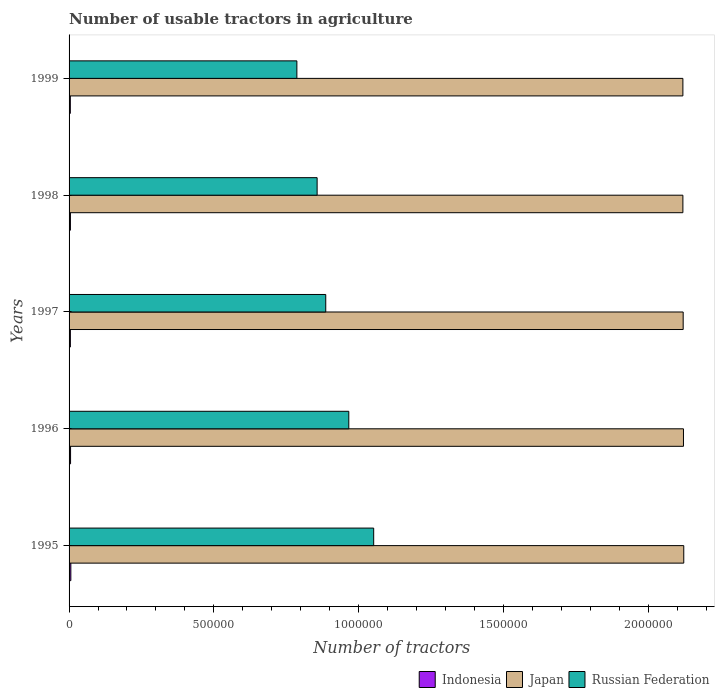Are the number of bars per tick equal to the number of legend labels?
Offer a very short reply. Yes. What is the number of usable tractors in agriculture in Indonesia in 1995?
Make the answer very short. 6124. Across all years, what is the maximum number of usable tractors in agriculture in Russian Federation?
Your response must be concise. 1.05e+06. Across all years, what is the minimum number of usable tractors in agriculture in Indonesia?
Ensure brevity in your answer.  4335. In which year was the number of usable tractors in agriculture in Russian Federation maximum?
Offer a terse response. 1995. What is the total number of usable tractors in agriculture in Japan in the graph?
Your answer should be very brief. 1.06e+07. What is the difference between the number of usable tractors in agriculture in Russian Federation in 1995 and that in 1996?
Ensure brevity in your answer.  8.60e+04. What is the difference between the number of usable tractors in agriculture in Russian Federation in 1997 and the number of usable tractors in agriculture in Indonesia in 1998?
Offer a very short reply. 8.82e+05. What is the average number of usable tractors in agriculture in Indonesia per year?
Provide a short and direct response. 4947.4. In the year 1998, what is the difference between the number of usable tractors in agriculture in Japan and number of usable tractors in agriculture in Russian Federation?
Your answer should be compact. 1.26e+06. What is the ratio of the number of usable tractors in agriculture in Indonesia in 1997 to that in 1999?
Give a very brief answer. 1.03. What is the difference between the highest and the second highest number of usable tractors in agriculture in Indonesia?
Give a very brief answer. 985. What is the difference between the highest and the lowest number of usable tractors in agriculture in Indonesia?
Offer a very short reply. 1789. What does the 1st bar from the top in 1999 represents?
Offer a very short reply. Russian Federation. What does the 3rd bar from the bottom in 1999 represents?
Your answer should be compact. Russian Federation. How many bars are there?
Make the answer very short. 15. How many years are there in the graph?
Offer a very short reply. 5. What is the difference between two consecutive major ticks on the X-axis?
Provide a short and direct response. 5.00e+05. Does the graph contain any zero values?
Your answer should be very brief. No. How many legend labels are there?
Your answer should be compact. 3. What is the title of the graph?
Your response must be concise. Number of usable tractors in agriculture. What is the label or title of the X-axis?
Provide a short and direct response. Number of tractors. What is the label or title of the Y-axis?
Offer a very short reply. Years. What is the Number of tractors of Indonesia in 1995?
Provide a succinct answer. 6124. What is the Number of tractors in Japan in 1995?
Provide a short and direct response. 2.12e+06. What is the Number of tractors of Russian Federation in 1995?
Provide a short and direct response. 1.05e+06. What is the Number of tractors of Indonesia in 1996?
Keep it short and to the point. 5139. What is the Number of tractors of Japan in 1996?
Your answer should be very brief. 2.12e+06. What is the Number of tractors in Russian Federation in 1996?
Make the answer very short. 9.66e+05. What is the Number of tractors of Indonesia in 1997?
Provide a short and direct response. 4483. What is the Number of tractors in Japan in 1997?
Give a very brief answer. 2.12e+06. What is the Number of tractors of Russian Federation in 1997?
Your answer should be very brief. 8.86e+05. What is the Number of tractors in Indonesia in 1998?
Ensure brevity in your answer.  4656. What is the Number of tractors in Japan in 1998?
Provide a succinct answer. 2.12e+06. What is the Number of tractors of Russian Federation in 1998?
Offer a terse response. 8.57e+05. What is the Number of tractors of Indonesia in 1999?
Provide a short and direct response. 4335. What is the Number of tractors in Japan in 1999?
Offer a terse response. 2.12e+06. What is the Number of tractors in Russian Federation in 1999?
Offer a terse response. 7.87e+05. Across all years, what is the maximum Number of tractors in Indonesia?
Keep it short and to the point. 6124. Across all years, what is the maximum Number of tractors in Japan?
Your answer should be compact. 2.12e+06. Across all years, what is the maximum Number of tractors of Russian Federation?
Offer a terse response. 1.05e+06. Across all years, what is the minimum Number of tractors of Indonesia?
Your answer should be compact. 4335. Across all years, what is the minimum Number of tractors of Japan?
Provide a succinct answer. 2.12e+06. Across all years, what is the minimum Number of tractors in Russian Federation?
Provide a succinct answer. 7.87e+05. What is the total Number of tractors of Indonesia in the graph?
Give a very brief answer. 2.47e+04. What is the total Number of tractors in Japan in the graph?
Your response must be concise. 1.06e+07. What is the total Number of tractors in Russian Federation in the graph?
Your response must be concise. 4.55e+06. What is the difference between the Number of tractors of Indonesia in 1995 and that in 1996?
Offer a terse response. 985. What is the difference between the Number of tractors in Japan in 1995 and that in 1996?
Offer a very short reply. 1000. What is the difference between the Number of tractors in Russian Federation in 1995 and that in 1996?
Your answer should be very brief. 8.60e+04. What is the difference between the Number of tractors of Indonesia in 1995 and that in 1997?
Offer a terse response. 1641. What is the difference between the Number of tractors in Russian Federation in 1995 and that in 1997?
Your answer should be compact. 1.66e+05. What is the difference between the Number of tractors in Indonesia in 1995 and that in 1998?
Keep it short and to the point. 1468. What is the difference between the Number of tractors of Japan in 1995 and that in 1998?
Ensure brevity in your answer.  3000. What is the difference between the Number of tractors of Russian Federation in 1995 and that in 1998?
Provide a short and direct response. 1.95e+05. What is the difference between the Number of tractors of Indonesia in 1995 and that in 1999?
Your answer should be very brief. 1789. What is the difference between the Number of tractors in Japan in 1995 and that in 1999?
Ensure brevity in your answer.  3000. What is the difference between the Number of tractors of Russian Federation in 1995 and that in 1999?
Provide a short and direct response. 2.65e+05. What is the difference between the Number of tractors of Indonesia in 1996 and that in 1997?
Give a very brief answer. 656. What is the difference between the Number of tractors in Russian Federation in 1996 and that in 1997?
Keep it short and to the point. 7.96e+04. What is the difference between the Number of tractors in Indonesia in 1996 and that in 1998?
Your response must be concise. 483. What is the difference between the Number of tractors of Japan in 1996 and that in 1998?
Offer a terse response. 2000. What is the difference between the Number of tractors in Russian Federation in 1996 and that in 1998?
Offer a terse response. 1.09e+05. What is the difference between the Number of tractors in Indonesia in 1996 and that in 1999?
Keep it short and to the point. 804. What is the difference between the Number of tractors of Japan in 1996 and that in 1999?
Provide a succinct answer. 2000. What is the difference between the Number of tractors of Russian Federation in 1996 and that in 1999?
Keep it short and to the point. 1.79e+05. What is the difference between the Number of tractors of Indonesia in 1997 and that in 1998?
Provide a succinct answer. -173. What is the difference between the Number of tractors of Japan in 1997 and that in 1998?
Offer a very short reply. 1000. What is the difference between the Number of tractors of Russian Federation in 1997 and that in 1998?
Your answer should be compact. 2.98e+04. What is the difference between the Number of tractors of Indonesia in 1997 and that in 1999?
Ensure brevity in your answer.  148. What is the difference between the Number of tractors of Russian Federation in 1997 and that in 1999?
Provide a succinct answer. 9.97e+04. What is the difference between the Number of tractors of Indonesia in 1998 and that in 1999?
Offer a very short reply. 321. What is the difference between the Number of tractors in Russian Federation in 1998 and that in 1999?
Ensure brevity in your answer.  6.99e+04. What is the difference between the Number of tractors of Indonesia in 1995 and the Number of tractors of Japan in 1996?
Provide a short and direct response. -2.12e+06. What is the difference between the Number of tractors of Indonesia in 1995 and the Number of tractors of Russian Federation in 1996?
Make the answer very short. -9.60e+05. What is the difference between the Number of tractors in Japan in 1995 and the Number of tractors in Russian Federation in 1996?
Ensure brevity in your answer.  1.16e+06. What is the difference between the Number of tractors of Indonesia in 1995 and the Number of tractors of Japan in 1997?
Offer a very short reply. -2.11e+06. What is the difference between the Number of tractors in Indonesia in 1995 and the Number of tractors in Russian Federation in 1997?
Ensure brevity in your answer.  -8.80e+05. What is the difference between the Number of tractors of Japan in 1995 and the Number of tractors of Russian Federation in 1997?
Provide a succinct answer. 1.24e+06. What is the difference between the Number of tractors of Indonesia in 1995 and the Number of tractors of Japan in 1998?
Offer a very short reply. -2.11e+06. What is the difference between the Number of tractors in Indonesia in 1995 and the Number of tractors in Russian Federation in 1998?
Make the answer very short. -8.51e+05. What is the difference between the Number of tractors in Japan in 1995 and the Number of tractors in Russian Federation in 1998?
Your response must be concise. 1.27e+06. What is the difference between the Number of tractors of Indonesia in 1995 and the Number of tractors of Japan in 1999?
Provide a succinct answer. -2.11e+06. What is the difference between the Number of tractors in Indonesia in 1995 and the Number of tractors in Russian Federation in 1999?
Your answer should be very brief. -7.81e+05. What is the difference between the Number of tractors in Japan in 1995 and the Number of tractors in Russian Federation in 1999?
Your answer should be compact. 1.34e+06. What is the difference between the Number of tractors in Indonesia in 1996 and the Number of tractors in Japan in 1997?
Your answer should be very brief. -2.12e+06. What is the difference between the Number of tractors in Indonesia in 1996 and the Number of tractors in Russian Federation in 1997?
Your answer should be very brief. -8.81e+05. What is the difference between the Number of tractors of Japan in 1996 and the Number of tractors of Russian Federation in 1997?
Your answer should be compact. 1.24e+06. What is the difference between the Number of tractors of Indonesia in 1996 and the Number of tractors of Japan in 1998?
Make the answer very short. -2.11e+06. What is the difference between the Number of tractors of Indonesia in 1996 and the Number of tractors of Russian Federation in 1998?
Make the answer very short. -8.52e+05. What is the difference between the Number of tractors in Japan in 1996 and the Number of tractors in Russian Federation in 1998?
Give a very brief answer. 1.27e+06. What is the difference between the Number of tractors in Indonesia in 1996 and the Number of tractors in Japan in 1999?
Offer a very short reply. -2.11e+06. What is the difference between the Number of tractors in Indonesia in 1996 and the Number of tractors in Russian Federation in 1999?
Your answer should be compact. -7.82e+05. What is the difference between the Number of tractors in Japan in 1996 and the Number of tractors in Russian Federation in 1999?
Provide a short and direct response. 1.34e+06. What is the difference between the Number of tractors of Indonesia in 1997 and the Number of tractors of Japan in 1998?
Give a very brief answer. -2.12e+06. What is the difference between the Number of tractors in Indonesia in 1997 and the Number of tractors in Russian Federation in 1998?
Ensure brevity in your answer.  -8.52e+05. What is the difference between the Number of tractors in Japan in 1997 and the Number of tractors in Russian Federation in 1998?
Ensure brevity in your answer.  1.26e+06. What is the difference between the Number of tractors in Indonesia in 1997 and the Number of tractors in Japan in 1999?
Offer a terse response. -2.12e+06. What is the difference between the Number of tractors in Indonesia in 1997 and the Number of tractors in Russian Federation in 1999?
Provide a succinct answer. -7.82e+05. What is the difference between the Number of tractors of Japan in 1997 and the Number of tractors of Russian Federation in 1999?
Provide a succinct answer. 1.33e+06. What is the difference between the Number of tractors of Indonesia in 1998 and the Number of tractors of Japan in 1999?
Keep it short and to the point. -2.12e+06. What is the difference between the Number of tractors of Indonesia in 1998 and the Number of tractors of Russian Federation in 1999?
Your answer should be compact. -7.82e+05. What is the difference between the Number of tractors of Japan in 1998 and the Number of tractors of Russian Federation in 1999?
Provide a succinct answer. 1.33e+06. What is the average Number of tractors of Indonesia per year?
Your answer should be compact. 4947.4. What is the average Number of tractors in Japan per year?
Make the answer very short. 2.12e+06. What is the average Number of tractors in Russian Federation per year?
Your response must be concise. 9.10e+05. In the year 1995, what is the difference between the Number of tractors in Indonesia and Number of tractors in Japan?
Offer a terse response. -2.12e+06. In the year 1995, what is the difference between the Number of tractors in Indonesia and Number of tractors in Russian Federation?
Provide a short and direct response. -1.05e+06. In the year 1995, what is the difference between the Number of tractors of Japan and Number of tractors of Russian Federation?
Make the answer very short. 1.07e+06. In the year 1996, what is the difference between the Number of tractors of Indonesia and Number of tractors of Japan?
Keep it short and to the point. -2.12e+06. In the year 1996, what is the difference between the Number of tractors of Indonesia and Number of tractors of Russian Federation?
Make the answer very short. -9.61e+05. In the year 1996, what is the difference between the Number of tractors in Japan and Number of tractors in Russian Federation?
Your answer should be compact. 1.16e+06. In the year 1997, what is the difference between the Number of tractors of Indonesia and Number of tractors of Japan?
Provide a short and direct response. -2.12e+06. In the year 1997, what is the difference between the Number of tractors in Indonesia and Number of tractors in Russian Federation?
Provide a succinct answer. -8.82e+05. In the year 1997, what is the difference between the Number of tractors in Japan and Number of tractors in Russian Federation?
Offer a very short reply. 1.23e+06. In the year 1998, what is the difference between the Number of tractors in Indonesia and Number of tractors in Japan?
Offer a terse response. -2.12e+06. In the year 1998, what is the difference between the Number of tractors of Indonesia and Number of tractors of Russian Federation?
Your response must be concise. -8.52e+05. In the year 1998, what is the difference between the Number of tractors of Japan and Number of tractors of Russian Federation?
Your answer should be compact. 1.26e+06. In the year 1999, what is the difference between the Number of tractors in Indonesia and Number of tractors in Japan?
Your answer should be compact. -2.12e+06. In the year 1999, what is the difference between the Number of tractors of Indonesia and Number of tractors of Russian Federation?
Provide a succinct answer. -7.82e+05. In the year 1999, what is the difference between the Number of tractors in Japan and Number of tractors in Russian Federation?
Provide a succinct answer. 1.33e+06. What is the ratio of the Number of tractors of Indonesia in 1995 to that in 1996?
Ensure brevity in your answer.  1.19. What is the ratio of the Number of tractors of Russian Federation in 1995 to that in 1996?
Ensure brevity in your answer.  1.09. What is the ratio of the Number of tractors of Indonesia in 1995 to that in 1997?
Your response must be concise. 1.37. What is the ratio of the Number of tractors in Japan in 1995 to that in 1997?
Your answer should be compact. 1. What is the ratio of the Number of tractors of Russian Federation in 1995 to that in 1997?
Ensure brevity in your answer.  1.19. What is the ratio of the Number of tractors in Indonesia in 1995 to that in 1998?
Your answer should be compact. 1.32. What is the ratio of the Number of tractors in Japan in 1995 to that in 1998?
Your answer should be compact. 1. What is the ratio of the Number of tractors in Russian Federation in 1995 to that in 1998?
Your response must be concise. 1.23. What is the ratio of the Number of tractors in Indonesia in 1995 to that in 1999?
Offer a very short reply. 1.41. What is the ratio of the Number of tractors in Russian Federation in 1995 to that in 1999?
Your answer should be compact. 1.34. What is the ratio of the Number of tractors of Indonesia in 1996 to that in 1997?
Ensure brevity in your answer.  1.15. What is the ratio of the Number of tractors in Russian Federation in 1996 to that in 1997?
Offer a terse response. 1.09. What is the ratio of the Number of tractors in Indonesia in 1996 to that in 1998?
Your answer should be very brief. 1.1. What is the ratio of the Number of tractors of Russian Federation in 1996 to that in 1998?
Offer a terse response. 1.13. What is the ratio of the Number of tractors of Indonesia in 1996 to that in 1999?
Your answer should be very brief. 1.19. What is the ratio of the Number of tractors in Japan in 1996 to that in 1999?
Your response must be concise. 1. What is the ratio of the Number of tractors of Russian Federation in 1996 to that in 1999?
Ensure brevity in your answer.  1.23. What is the ratio of the Number of tractors of Indonesia in 1997 to that in 1998?
Your response must be concise. 0.96. What is the ratio of the Number of tractors in Japan in 1997 to that in 1998?
Give a very brief answer. 1. What is the ratio of the Number of tractors in Russian Federation in 1997 to that in 1998?
Make the answer very short. 1.03. What is the ratio of the Number of tractors in Indonesia in 1997 to that in 1999?
Provide a short and direct response. 1.03. What is the ratio of the Number of tractors in Japan in 1997 to that in 1999?
Provide a succinct answer. 1. What is the ratio of the Number of tractors of Russian Federation in 1997 to that in 1999?
Give a very brief answer. 1.13. What is the ratio of the Number of tractors of Indonesia in 1998 to that in 1999?
Keep it short and to the point. 1.07. What is the ratio of the Number of tractors in Japan in 1998 to that in 1999?
Offer a very short reply. 1. What is the ratio of the Number of tractors in Russian Federation in 1998 to that in 1999?
Your answer should be very brief. 1.09. What is the difference between the highest and the second highest Number of tractors in Indonesia?
Offer a very short reply. 985. What is the difference between the highest and the second highest Number of tractors of Japan?
Provide a short and direct response. 1000. What is the difference between the highest and the second highest Number of tractors of Russian Federation?
Offer a terse response. 8.60e+04. What is the difference between the highest and the lowest Number of tractors of Indonesia?
Give a very brief answer. 1789. What is the difference between the highest and the lowest Number of tractors in Japan?
Offer a terse response. 3000. What is the difference between the highest and the lowest Number of tractors of Russian Federation?
Your answer should be very brief. 2.65e+05. 